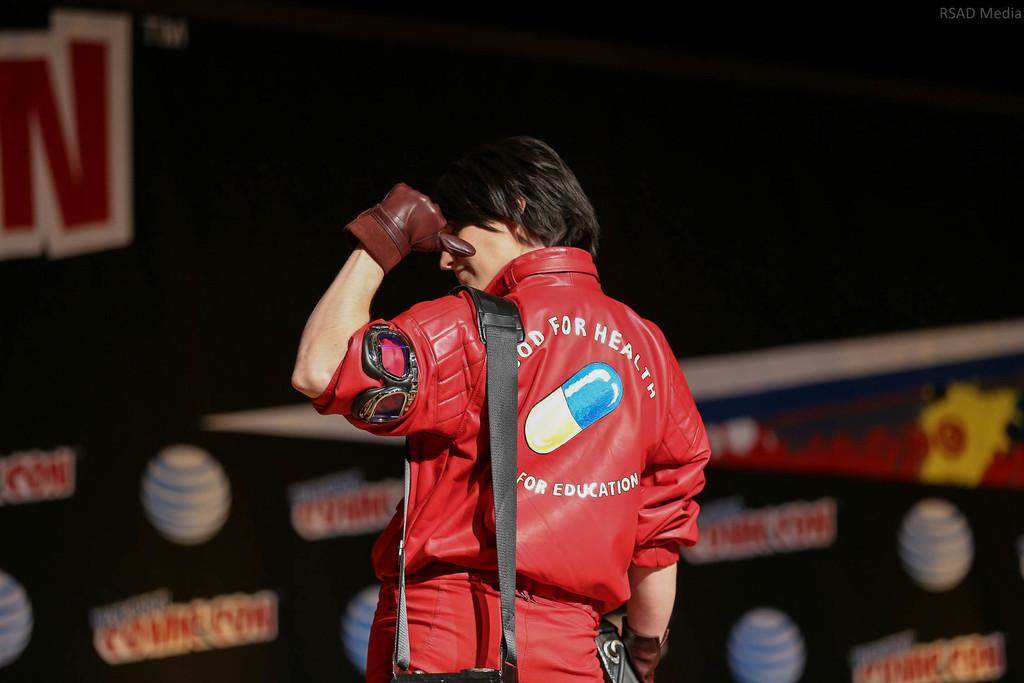<image>
Share a concise interpretation of the image provided. A person points to the back of their red jacket that says Good For Health with a picture of a pill. 